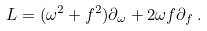<formula> <loc_0><loc_0><loc_500><loc_500>L = ( \omega ^ { 2 } + f ^ { 2 } ) \partial _ { \omega } + 2 \omega f \partial _ { f } \, .</formula> 